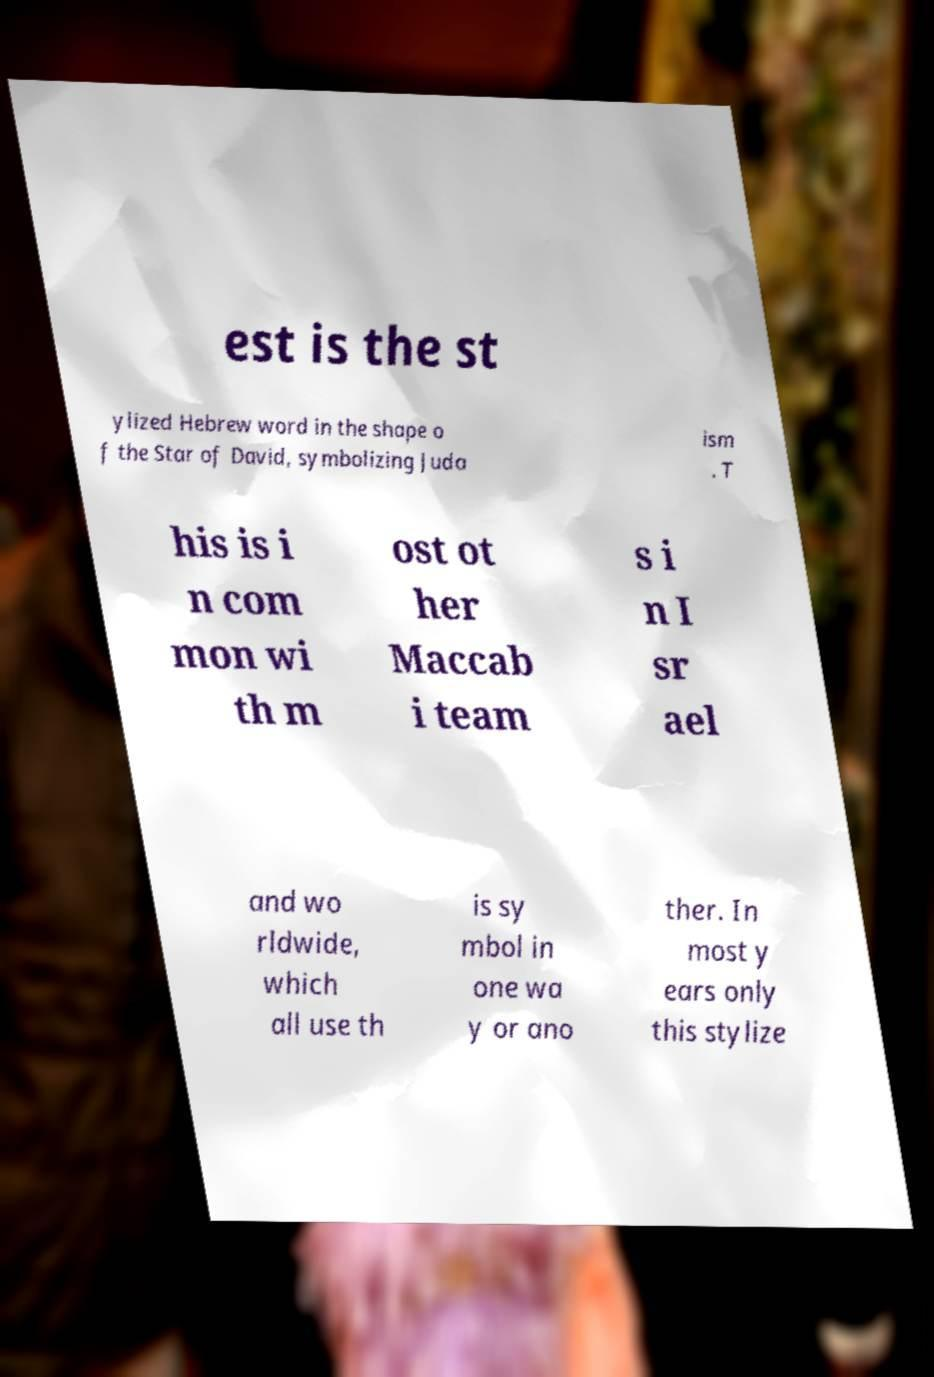Please read and relay the text visible in this image. What does it say? est is the st ylized Hebrew word in the shape o f the Star of David, symbolizing Juda ism . T his is i n com mon wi th m ost ot her Maccab i team s i n I sr ael and wo rldwide, which all use th is sy mbol in one wa y or ano ther. In most y ears only this stylize 